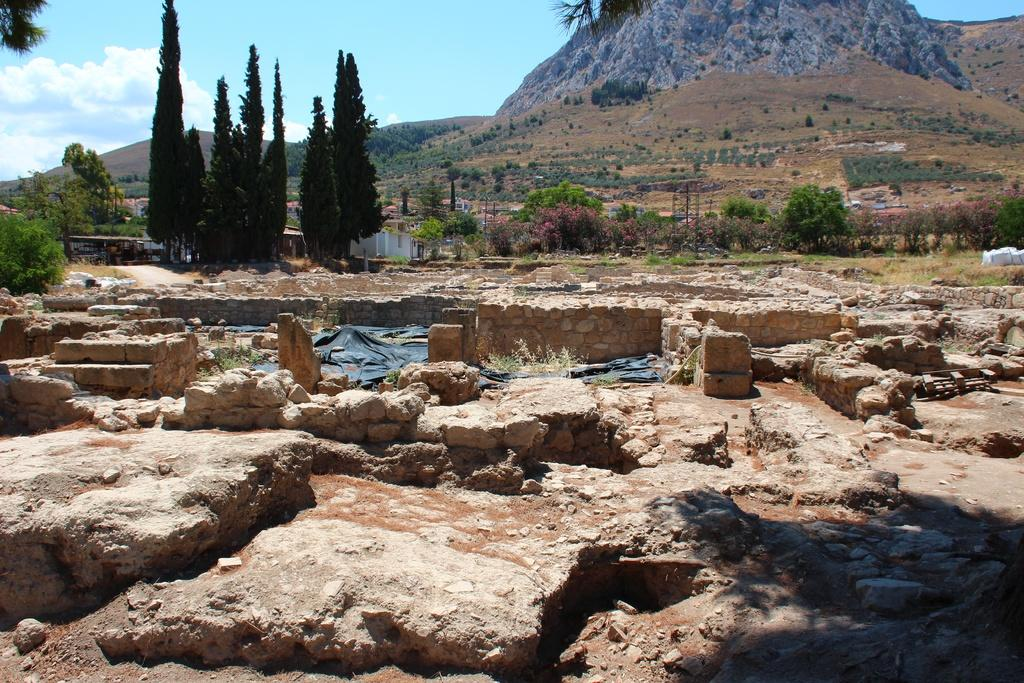What type of natural elements can be seen in the image? There are stones in the image. What can be seen in the background of the image? There are trees, mountains, houses, and the sky visible in the background of the image. What type of fruit is being used to decorate the stones in the image? There is no fruit present in the image; it features stones, trees, mountains, houses, and the sky in the background. 